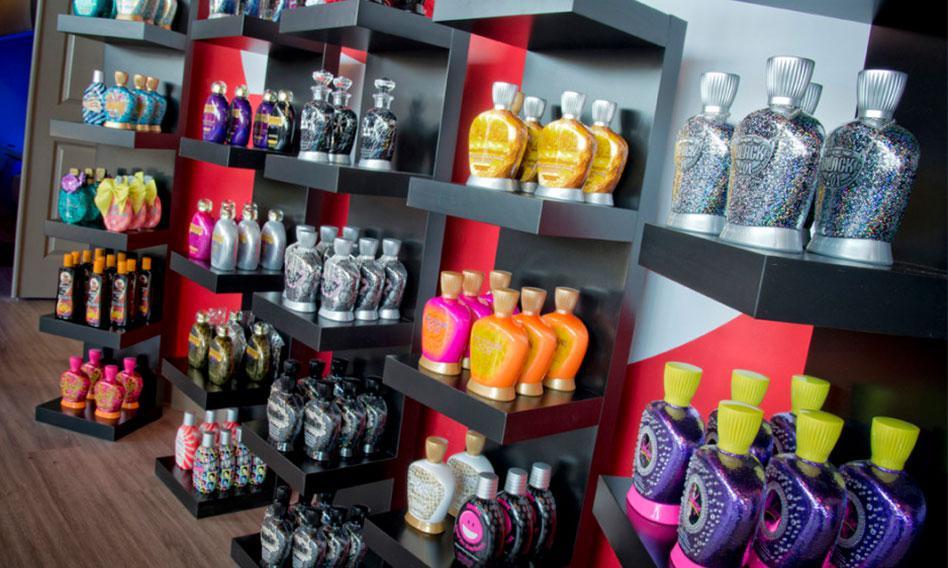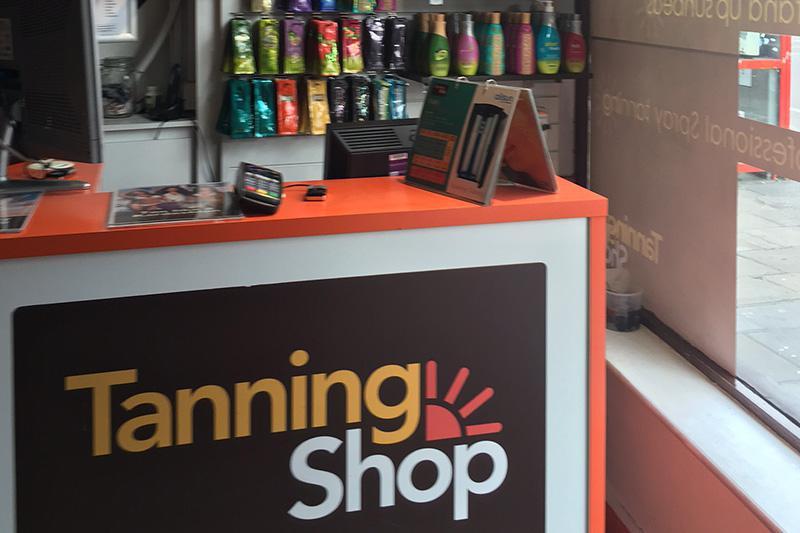The first image is the image on the left, the second image is the image on the right. Assess this claim about the two images: "Many different kinds of tanning lotion hang behind a booth that reads Tanning Shop.". Correct or not? Answer yes or no. Yes. The first image is the image on the left, the second image is the image on the right. For the images shown, is this caption "Below the salable items, you'll notice the words, """"Tanning Shop""""" true? Answer yes or no. Yes. 